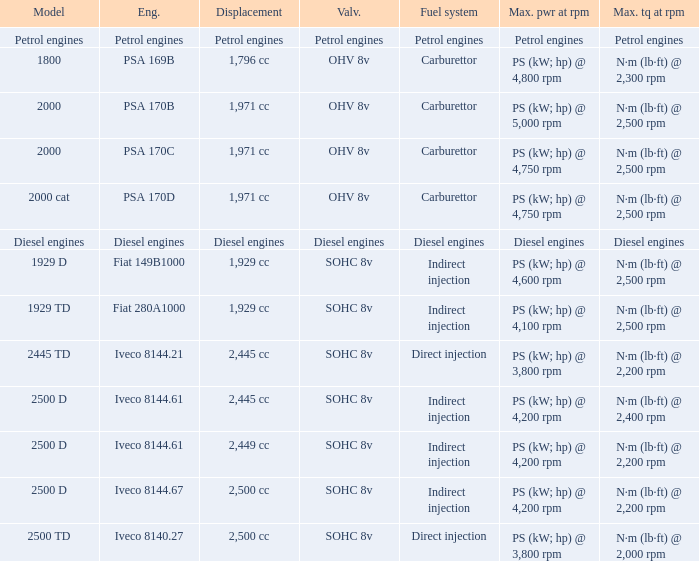What Valvetrain has a fuel system made up of petrol engines? Petrol engines. 